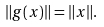<formula> <loc_0><loc_0><loc_500><loc_500>\| g ( x ) \| = \| x \| .</formula> 